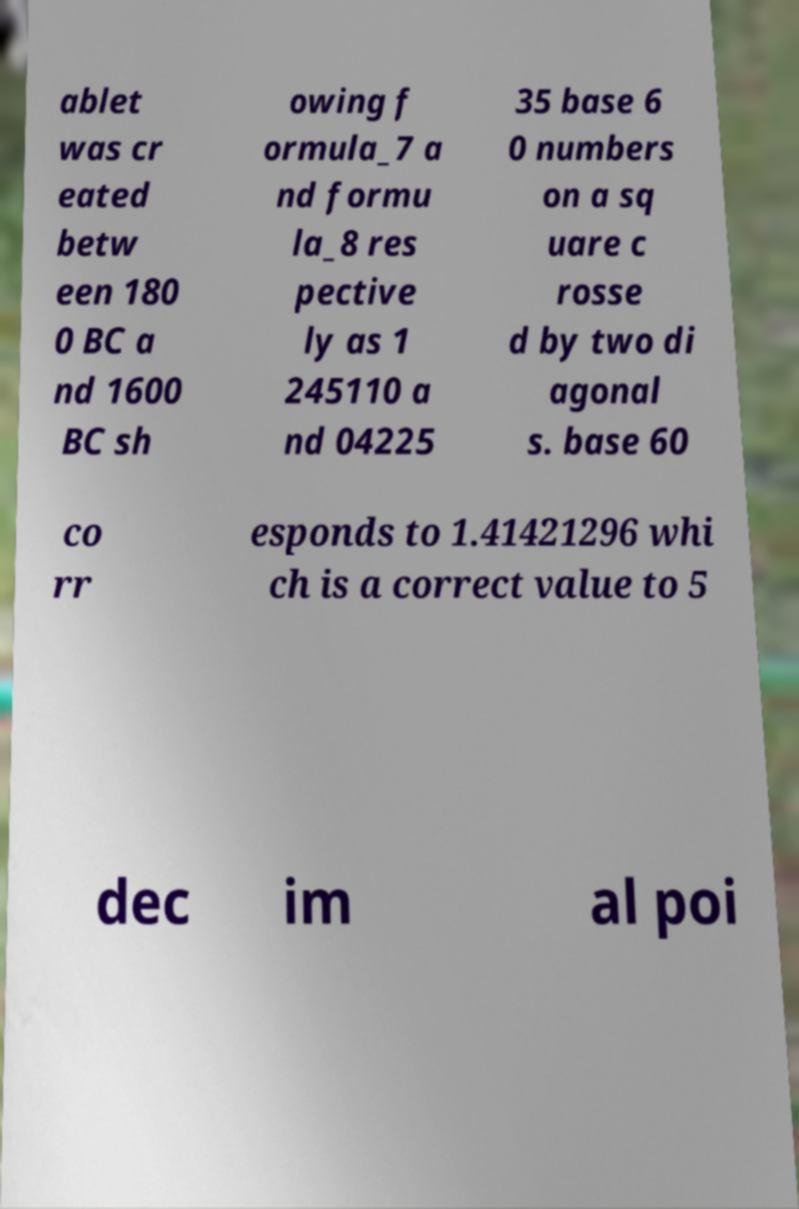Can you accurately transcribe the text from the provided image for me? ablet was cr eated betw een 180 0 BC a nd 1600 BC sh owing f ormula_7 a nd formu la_8 res pective ly as 1 245110 a nd 04225 35 base 6 0 numbers on a sq uare c rosse d by two di agonal s. base 60 co rr esponds to 1.41421296 whi ch is a correct value to 5 dec im al poi 